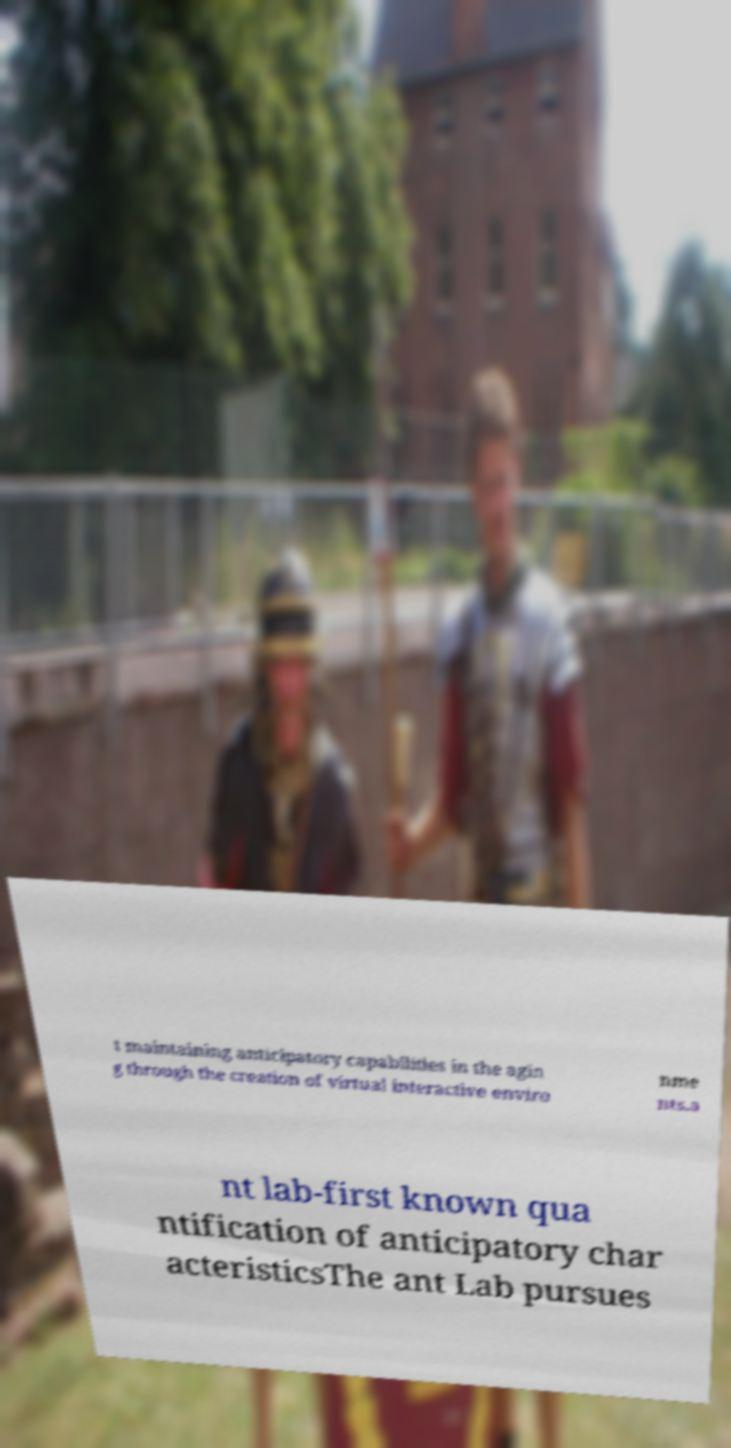I need the written content from this picture converted into text. Can you do that? t maintaining anticipatory capabilities in the agin g through the creation of virtual interactive enviro nme nts.a nt lab-first known qua ntification of anticipatory char acteristicsThe ant Lab pursues 